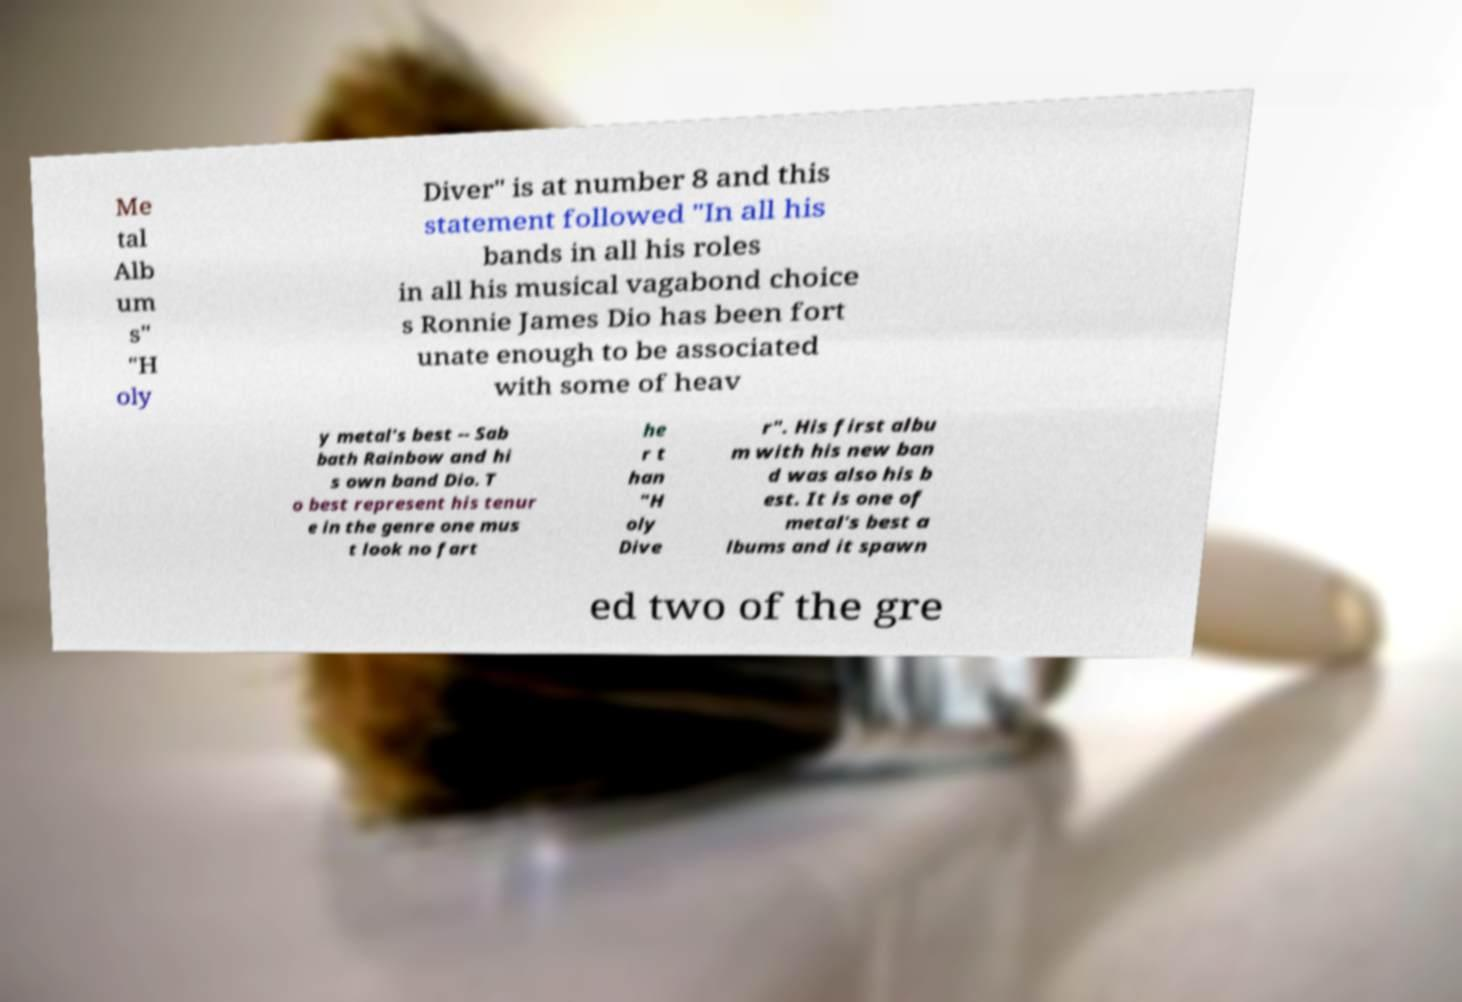I need the written content from this picture converted into text. Can you do that? Me tal Alb um s" "H oly Diver" is at number 8 and this statement followed "In all his bands in all his roles in all his musical vagabond choice s Ronnie James Dio has been fort unate enough to be associated with some of heav y metal's best -- Sab bath Rainbow and hi s own band Dio. T o best represent his tenur e in the genre one mus t look no fart he r t han "H oly Dive r". His first albu m with his new ban d was also his b est. It is one of metal's best a lbums and it spawn ed two of the gre 